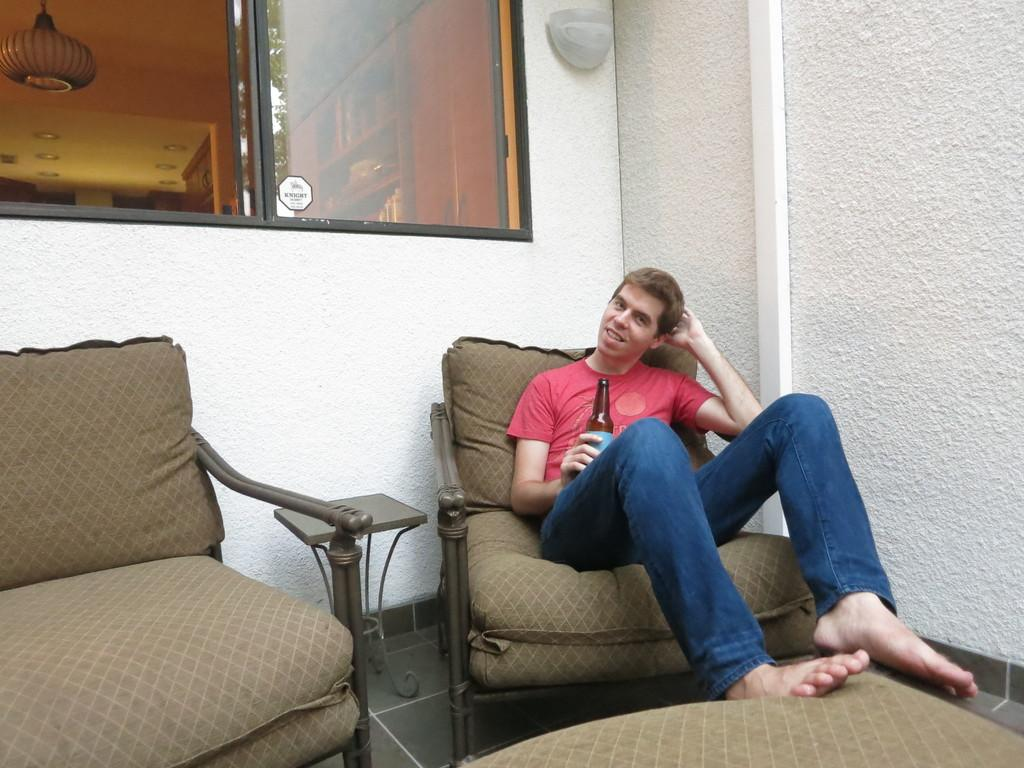What is the person in the image doing? The person is sitting on a chair in the image. What object is the person holding? The person is holding a bottle. What can be seen behind the person? There is a window behind the person. What color is the wall on the right side of the image? The wall on the right side of the image is white. What type of question is being asked in the church depicted in the image? There is no church present in the image, and therefore no question being asked. 